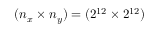<formula> <loc_0><loc_0><loc_500><loc_500>( n _ { x } \times n _ { y } ) = ( 2 ^ { 1 2 } \times 2 ^ { 1 2 } )</formula> 